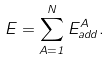<formula> <loc_0><loc_0><loc_500><loc_500>E = \sum _ { A = 1 } ^ { N } E _ { a d d } ^ { A } .</formula> 